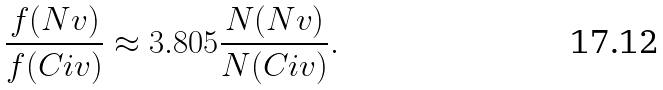<formula> <loc_0><loc_0><loc_500><loc_500>\frac { f ( N { v } ) } { f ( C { i v } ) } \approx 3 . 8 0 5 \frac { N ( N { v } ) } { N ( C { i v } ) } .</formula> 